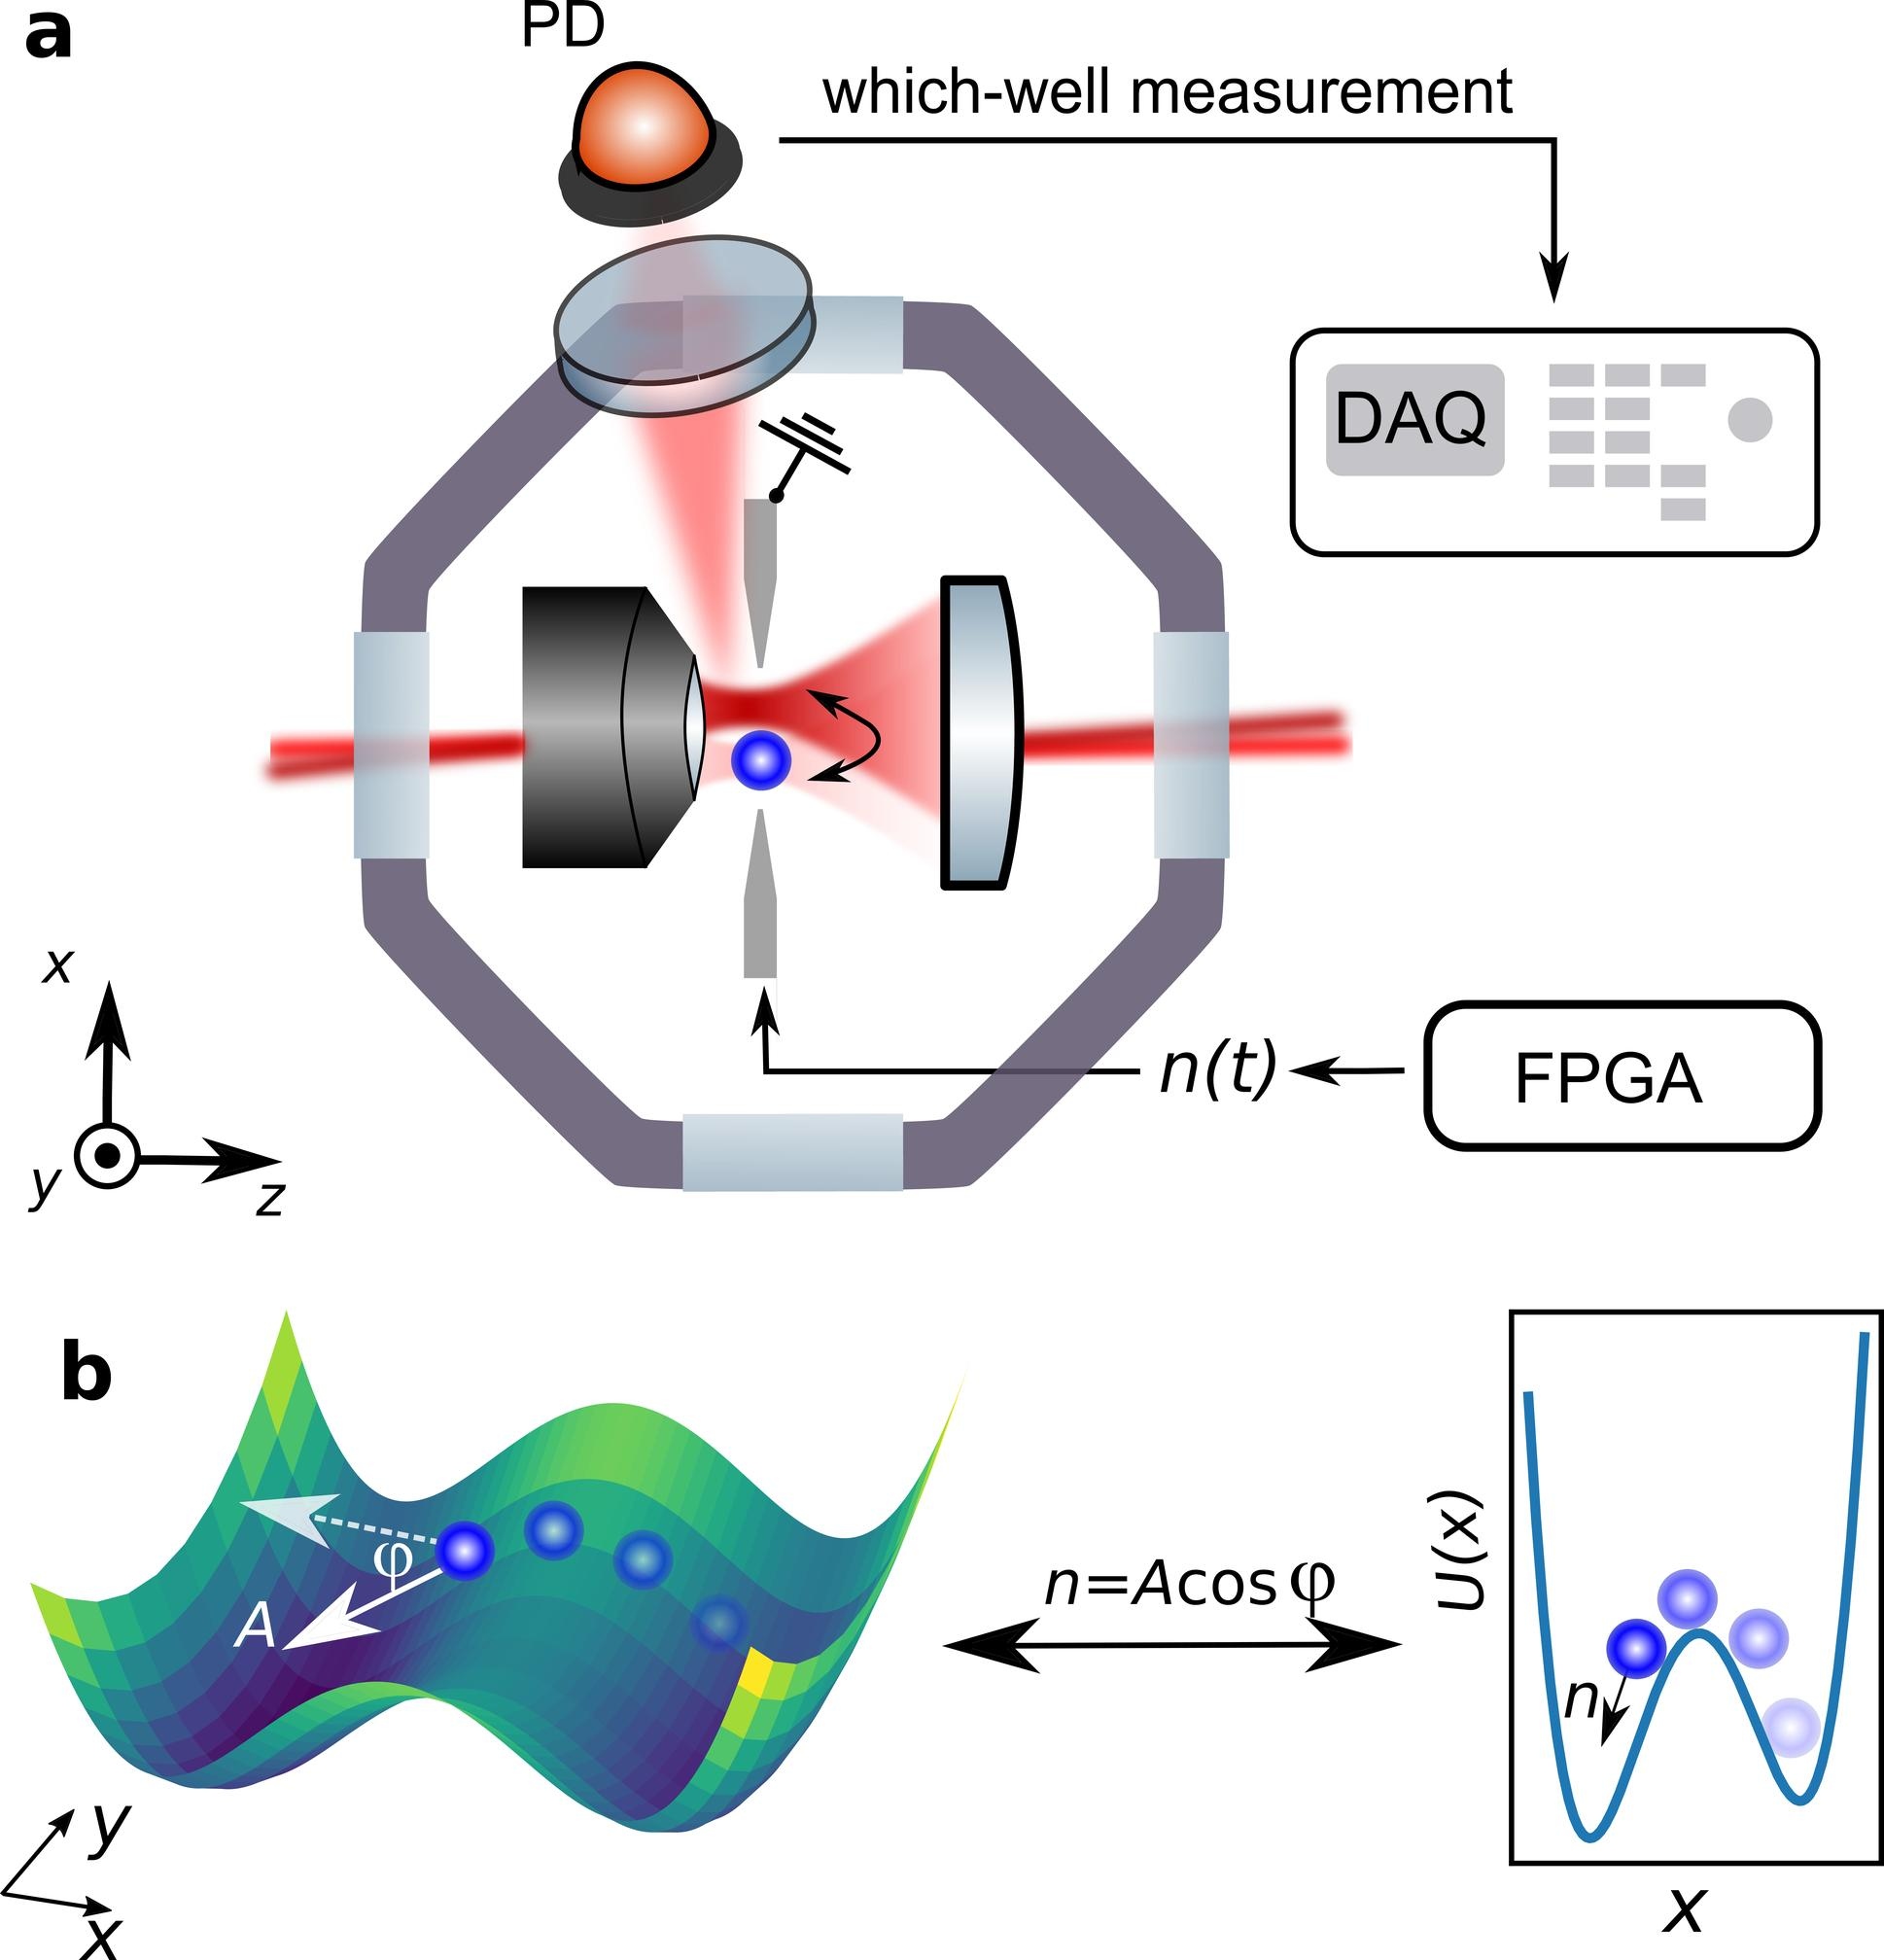Based on Figure b, what is the relationship between "n" and "03c6"? A. n is directly proportional to 03c6. B. n is the amplitude of oscillation as a function of 03c6. C. n is a constant multiplied by the cosine of 03c6. D. n is the potential energy as a function of 03c6. In Figure b, the expression 'n=Acos(03c6)' illustrates an important relationship in the context of the depicted phenomenon. Here, 'n' represents a value that is determined by the product of a certain constant 'A,' which can be interpreted as the amplitude, and the cosine of the angle '03c6'. This relationship implies that 'n' oscillates about zero, with its maximum deviation from zero being 'A', and it varies according to the cosine function of '03c6'. Since the question asks us to determine how 'n' is mathematically related to '03c6', the accurate answer is option C: n is a constant multiplied by the cosine of 03c6. Understanding this relationship helps in grasping the basics of oscillatory motion depicted in the graph, where 'n' represents a measurable variable dependent on the angular displacement '03c6'. 